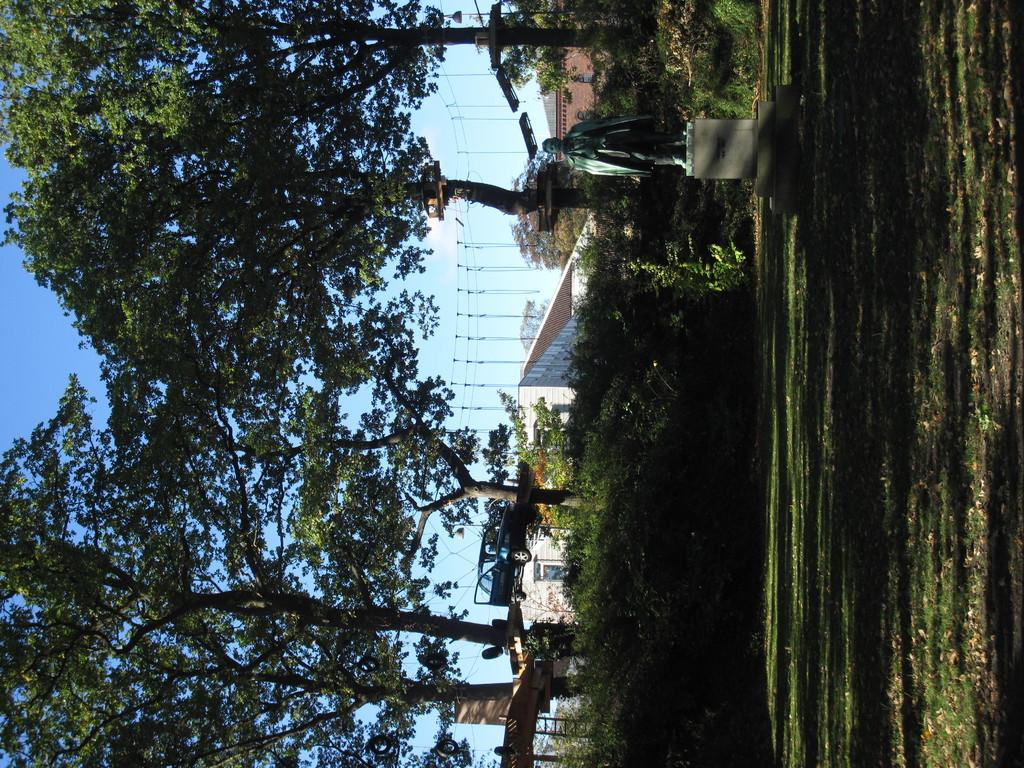What type of structure is visible in the image? There is a building in the image. What type of vegetation can be seen in the image? There are trees in the image. What other object is present in the image besides the building and trees? There is a statue in the image. What is the ground covered with in the image? The ground is covered with grass in the image. What color is the sky in the image? The sky is blue in the image. How many servants are attending to the station in the image? There is no station or servants present in the image. What fact is being presented in the image? The image itself is not presenting a fact; it is a visual representation of a scene. 